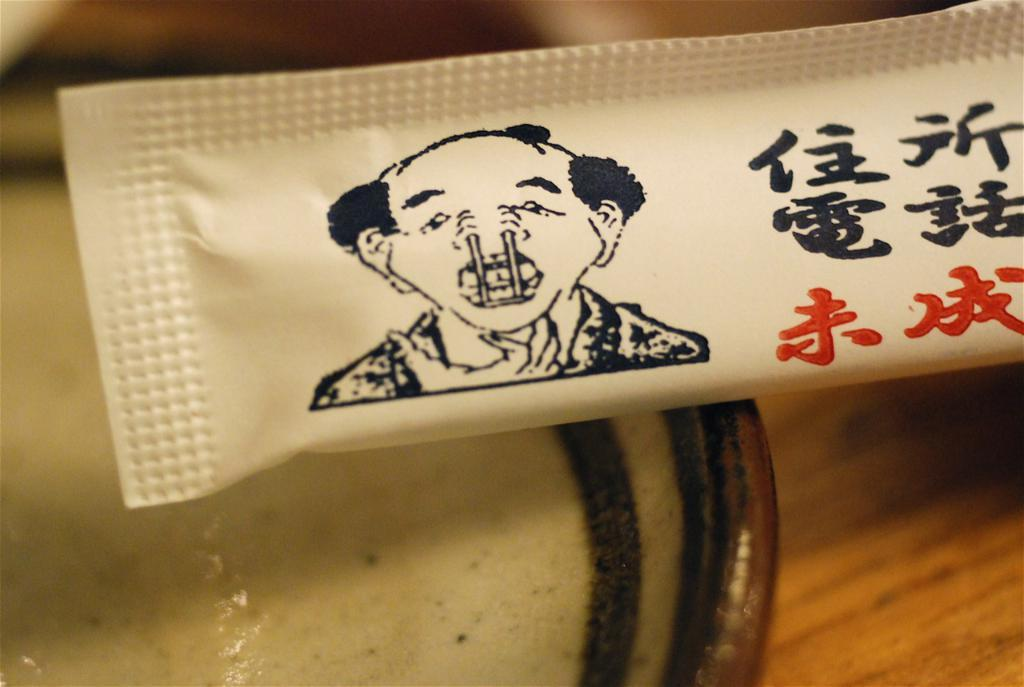What is the main piece of furniture in the image? There is a table in the image. What is placed on the table? There is a bowl and a sachet placed on the table. What type of discussion is taking place at the table in the image? There is no discussion taking place in the image; it only shows a table with a bowl and a sachet on it. 